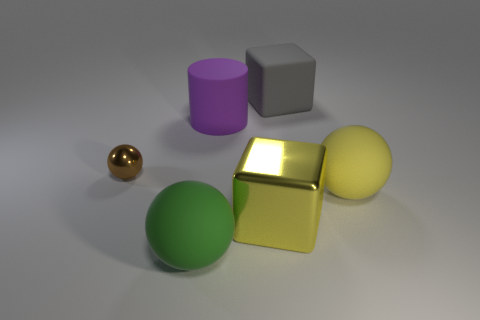Add 3 big objects. How many objects exist? 9 Subtract all cubes. How many objects are left? 4 Subtract all tiny brown objects. Subtract all tiny yellow matte blocks. How many objects are left? 5 Add 2 big rubber cylinders. How many big rubber cylinders are left? 3 Add 3 small metal things. How many small metal things exist? 4 Subtract 0 yellow cylinders. How many objects are left? 6 